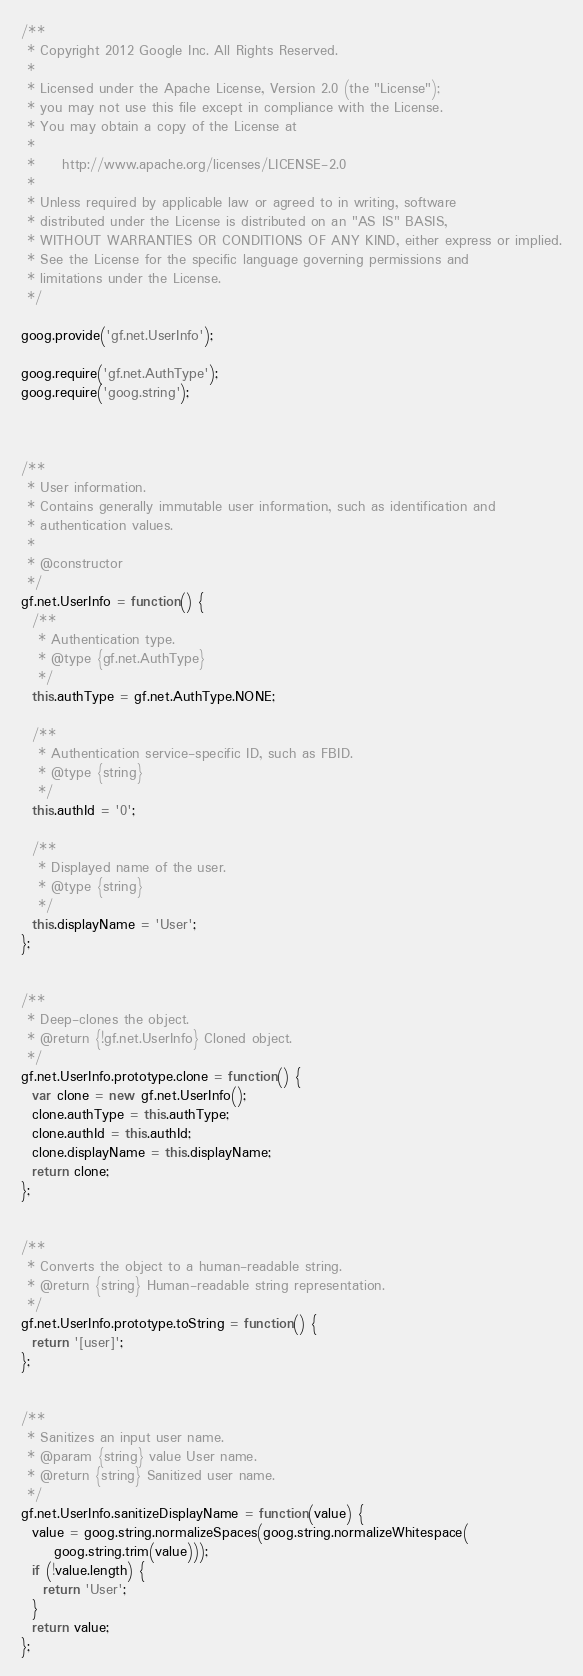Convert code to text. <code><loc_0><loc_0><loc_500><loc_500><_JavaScript_>/**
 * Copyright 2012 Google Inc. All Rights Reserved.
 *
 * Licensed under the Apache License, Version 2.0 (the "License");
 * you may not use this file except in compliance with the License.
 * You may obtain a copy of the License at
 *
 *     http://www.apache.org/licenses/LICENSE-2.0
 *
 * Unless required by applicable law or agreed to in writing, software
 * distributed under the License is distributed on an "AS IS" BASIS,
 * WITHOUT WARRANTIES OR CONDITIONS OF ANY KIND, either express or implied.
 * See the License for the specific language governing permissions and
 * limitations under the License.
 */

goog.provide('gf.net.UserInfo');

goog.require('gf.net.AuthType');
goog.require('goog.string');



/**
 * User information.
 * Contains generally immutable user information, such as identification and
 * authentication values.
 *
 * @constructor
 */
gf.net.UserInfo = function() {
  /**
   * Authentication type.
   * @type {gf.net.AuthType}
   */
  this.authType = gf.net.AuthType.NONE;

  /**
   * Authentication service-specific ID, such as FBID.
   * @type {string}
   */
  this.authId = '0';

  /**
   * Displayed name of the user.
   * @type {string}
   */
  this.displayName = 'User';
};


/**
 * Deep-clones the object.
 * @return {!gf.net.UserInfo} Cloned object.
 */
gf.net.UserInfo.prototype.clone = function() {
  var clone = new gf.net.UserInfo();
  clone.authType = this.authType;
  clone.authId = this.authId;
  clone.displayName = this.displayName;
  return clone;
};


/**
 * Converts the object to a human-readable string.
 * @return {string} Human-readable string representation.
 */
gf.net.UserInfo.prototype.toString = function() {
  return '[user]';
};


/**
 * Sanitizes an input user name.
 * @param {string} value User name.
 * @return {string} Sanitized user name.
 */
gf.net.UserInfo.sanitizeDisplayName = function(value) {
  value = goog.string.normalizeSpaces(goog.string.normalizeWhitespace(
      goog.string.trim(value)));
  if (!value.length) {
    return 'User';
  }
  return value;
};
</code> 